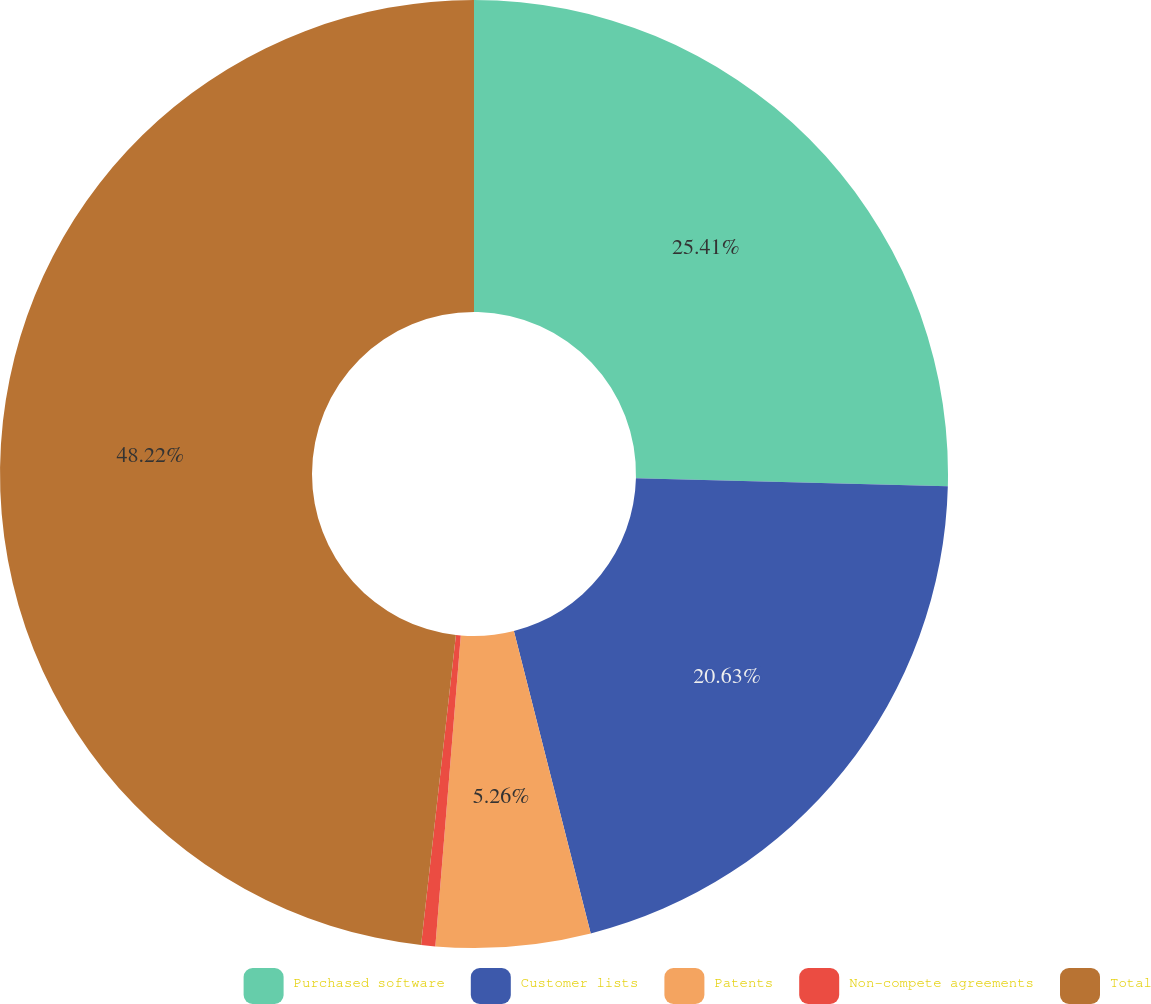Convert chart to OTSL. <chart><loc_0><loc_0><loc_500><loc_500><pie_chart><fcel>Purchased software<fcel>Customer lists<fcel>Patents<fcel>Non-compete agreements<fcel>Total<nl><fcel>25.41%<fcel>20.63%<fcel>5.26%<fcel>0.48%<fcel>48.22%<nl></chart> 